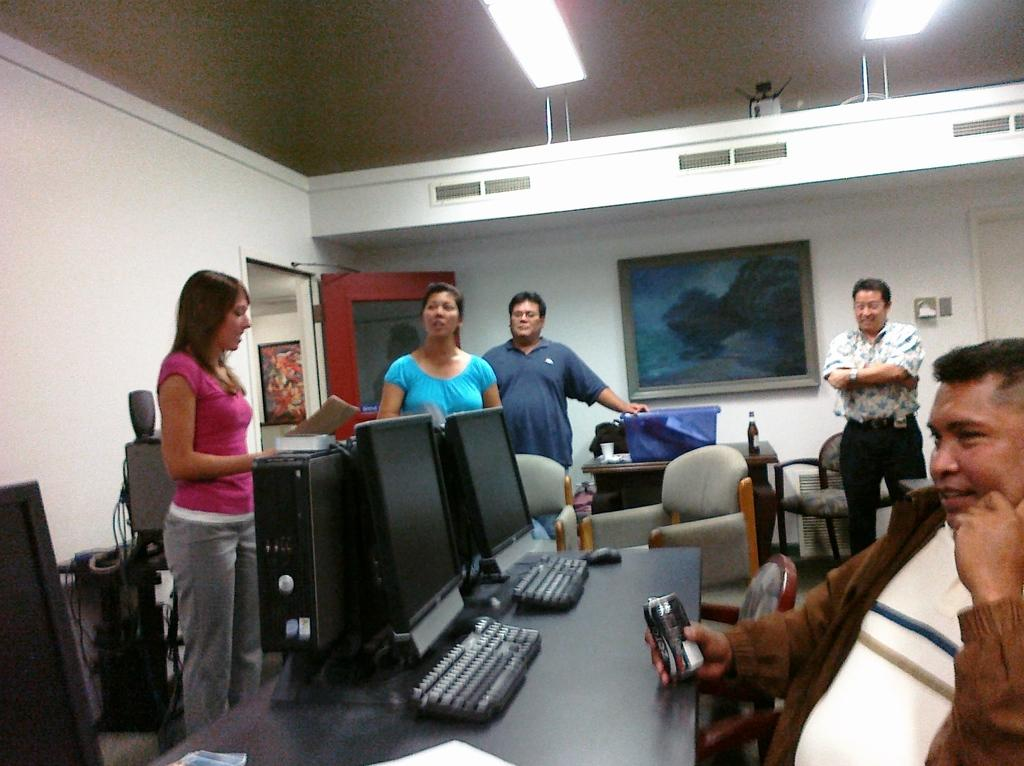How many people are present in the room in the image? There are many people standing in the room. What is the man in the room doing? The man is sitting in the room and holding a coke tin. What type of equipment can be seen in the room? There are monitors and keyboards on a table in the room. What type of twig is being used as a low dust cover in the image? There is no twig or dust cover present in the image. 